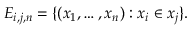Convert formula to latex. <formula><loc_0><loc_0><loc_500><loc_500>E _ { i , j , n } = \{ ( x _ { 1 } , \dots , x _ { n } ) \colon x _ { i } \in x _ { j } \} .</formula> 